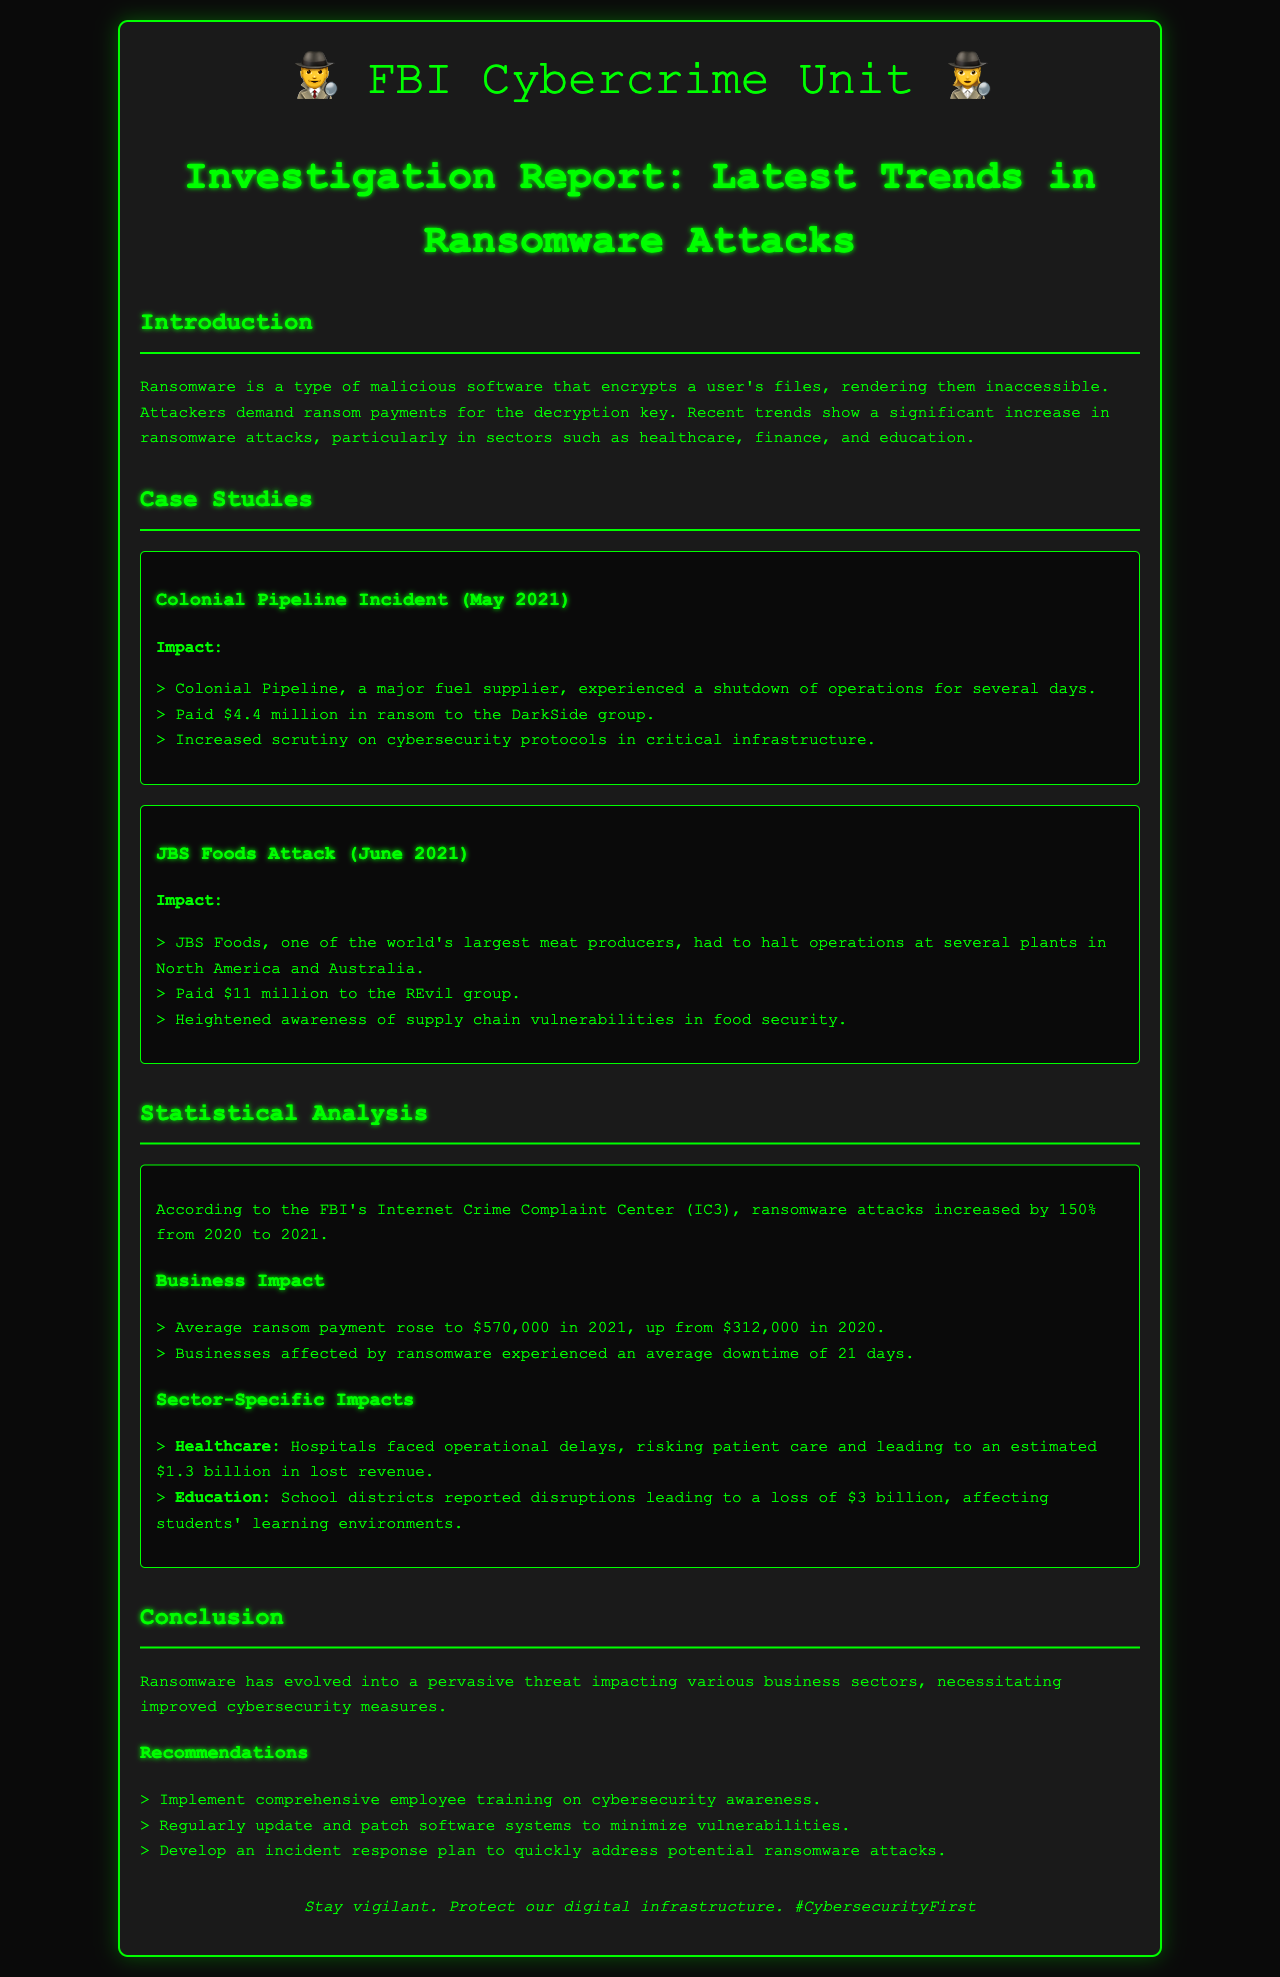What was the impact of the Colonial Pipeline incident? The impact included a shutdown of operations for several days and a ransom payment of $4.4 million.
Answer: Shutdown for several days, $4.4 million What was the average ransom payment in 2021? The average ransom payment rose to $570,000 in 2021, as stated in the statistical analysis section.
Answer: $570,000 Which sector experienced an estimated $1.3 billion in lost revenue due to ransomware? The healthcare sector faced this significant financial impact, as noted in the statistical analysis.
Answer: Healthcare What was the increase percentage of ransomware attacks from 2020 to 2021? The report states that ransomware attacks increased by 150% from 2020 to 2021 according to the FBI's IC3.
Answer: 150% What are two recommendations for improving cybersecurity? Two recommendations mentioned are to implement employee training and regularly update software systems.
Answer: Employee training, update software systems How much did JBS Foods pay to the REvil group? The report indicates that JBS Foods paid $11 million in ransom to the REvil group during the attack in June 2021.
Answer: $11 million What was the average downtime for businesses affected by ransomware? The document states that businesses experienced an average downtime of 21 days due to ransomware attacks.
Answer: 21 days What significant threat has evolved according to the conclusion? The conclusion states that ransomware has evolved into a pervasive threat affecting various business sectors.
Answer: Ransomware 